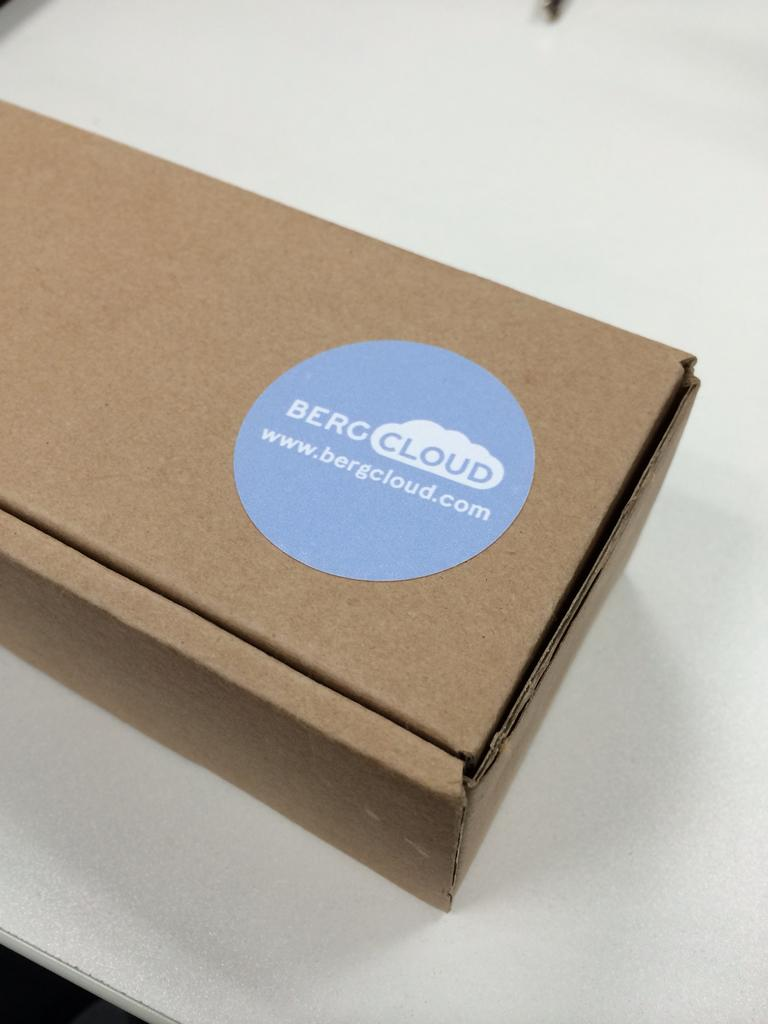<image>
Write a terse but informative summary of the picture. Brown box with a circule blue sticker that says "BERGCLOUD". 